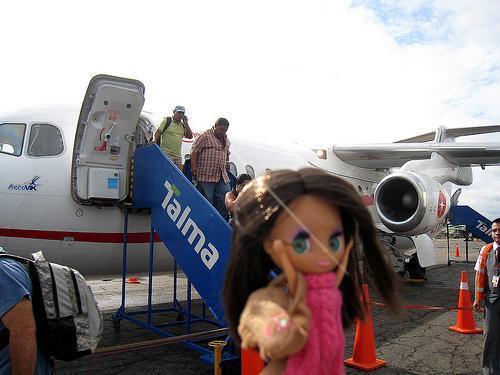How many people are in the photo?
Give a very brief answer. 5. 